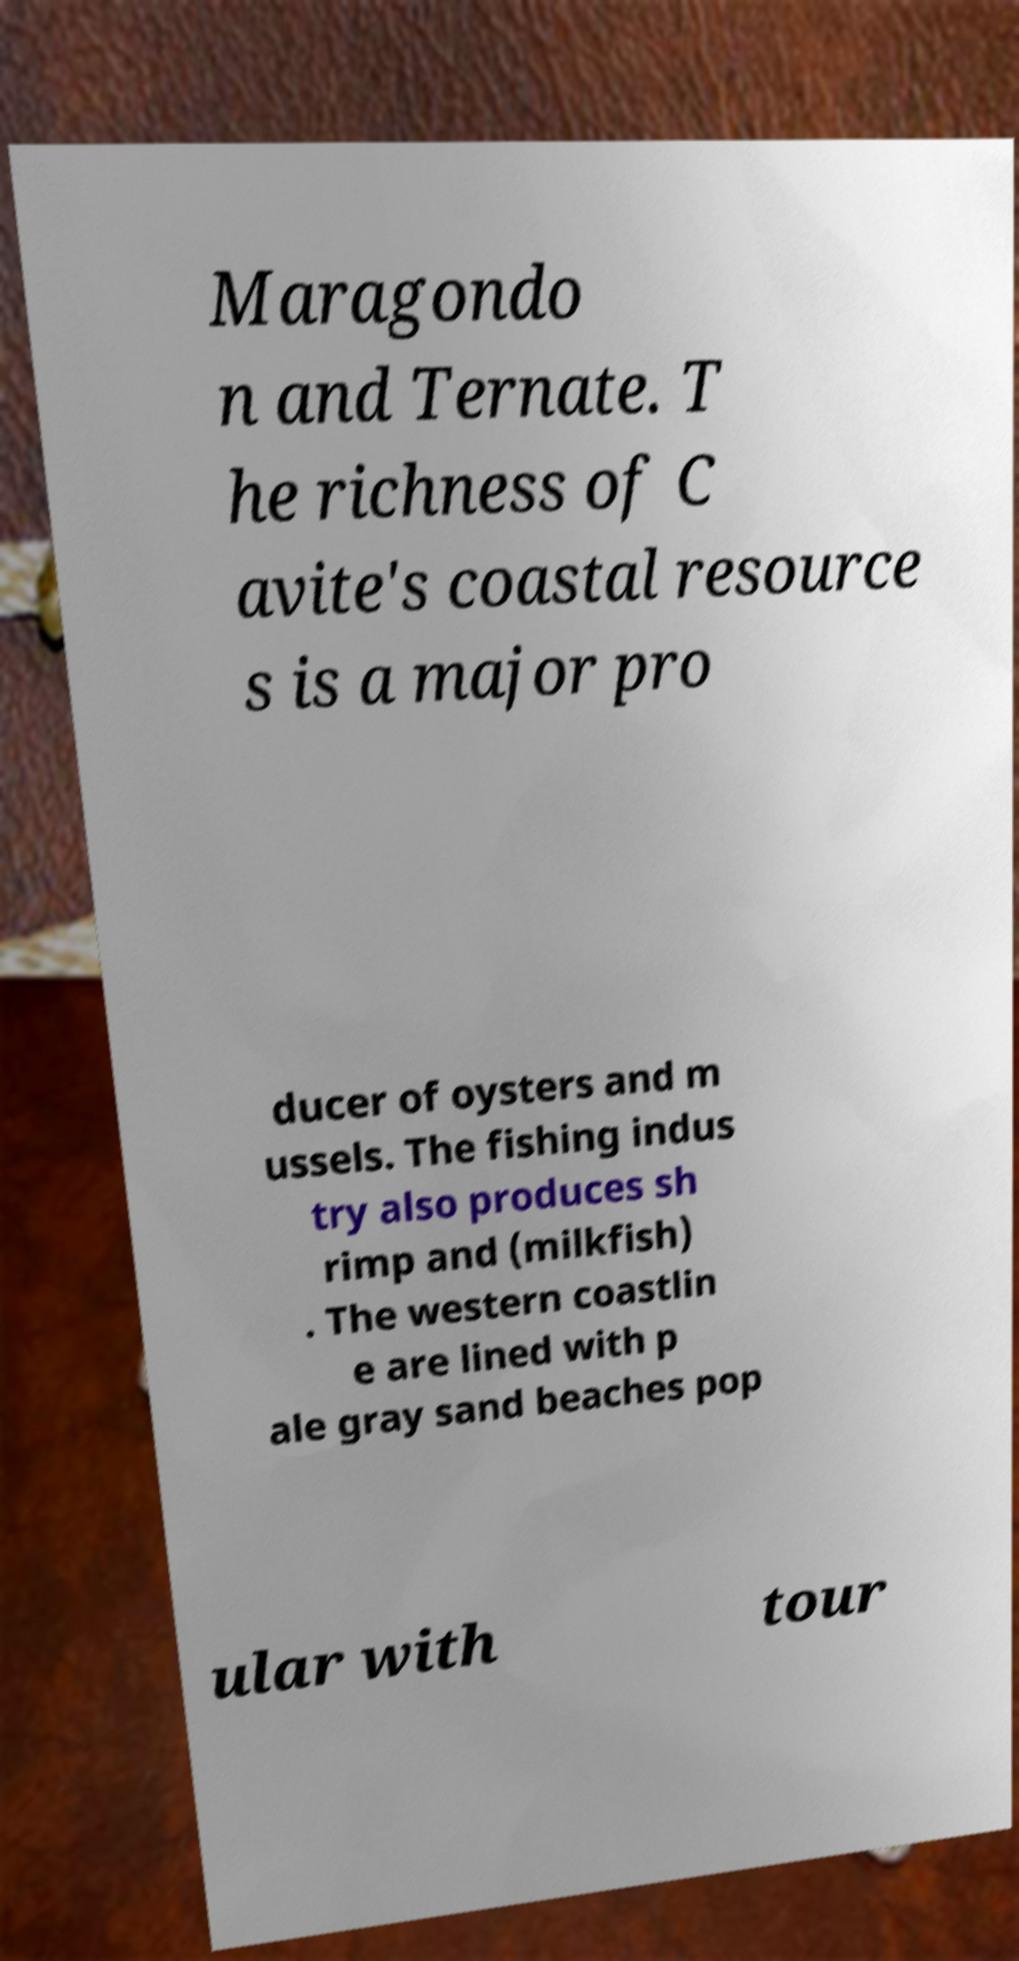Could you extract and type out the text from this image? Maragondo n and Ternate. T he richness of C avite's coastal resource s is a major pro ducer of oysters and m ussels. The fishing indus try also produces sh rimp and (milkfish) . The western coastlin e are lined with p ale gray sand beaches pop ular with tour 